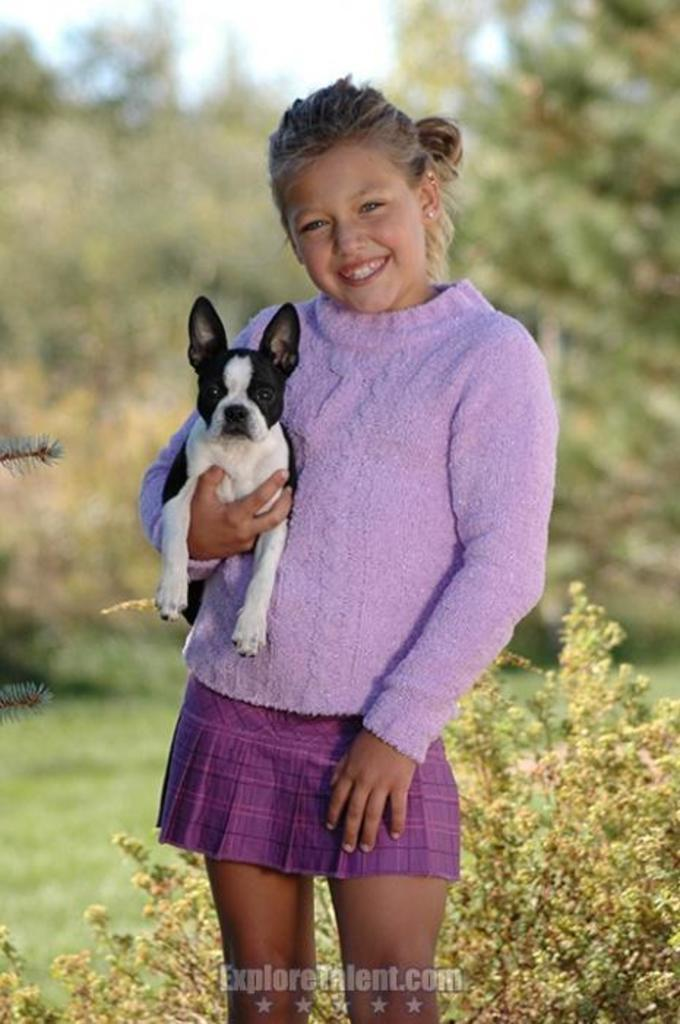What is the main subject of the image? The main subject of the image is a kid. What is the kid doing in the image? The kid is holding a dog and smiling. What else can be seen in the image besides the kid and the dog? There are plants visible in the image. What type of bell can be heard ringing in the image? There is no bell present in the image, and therefore no sound can be heard. 